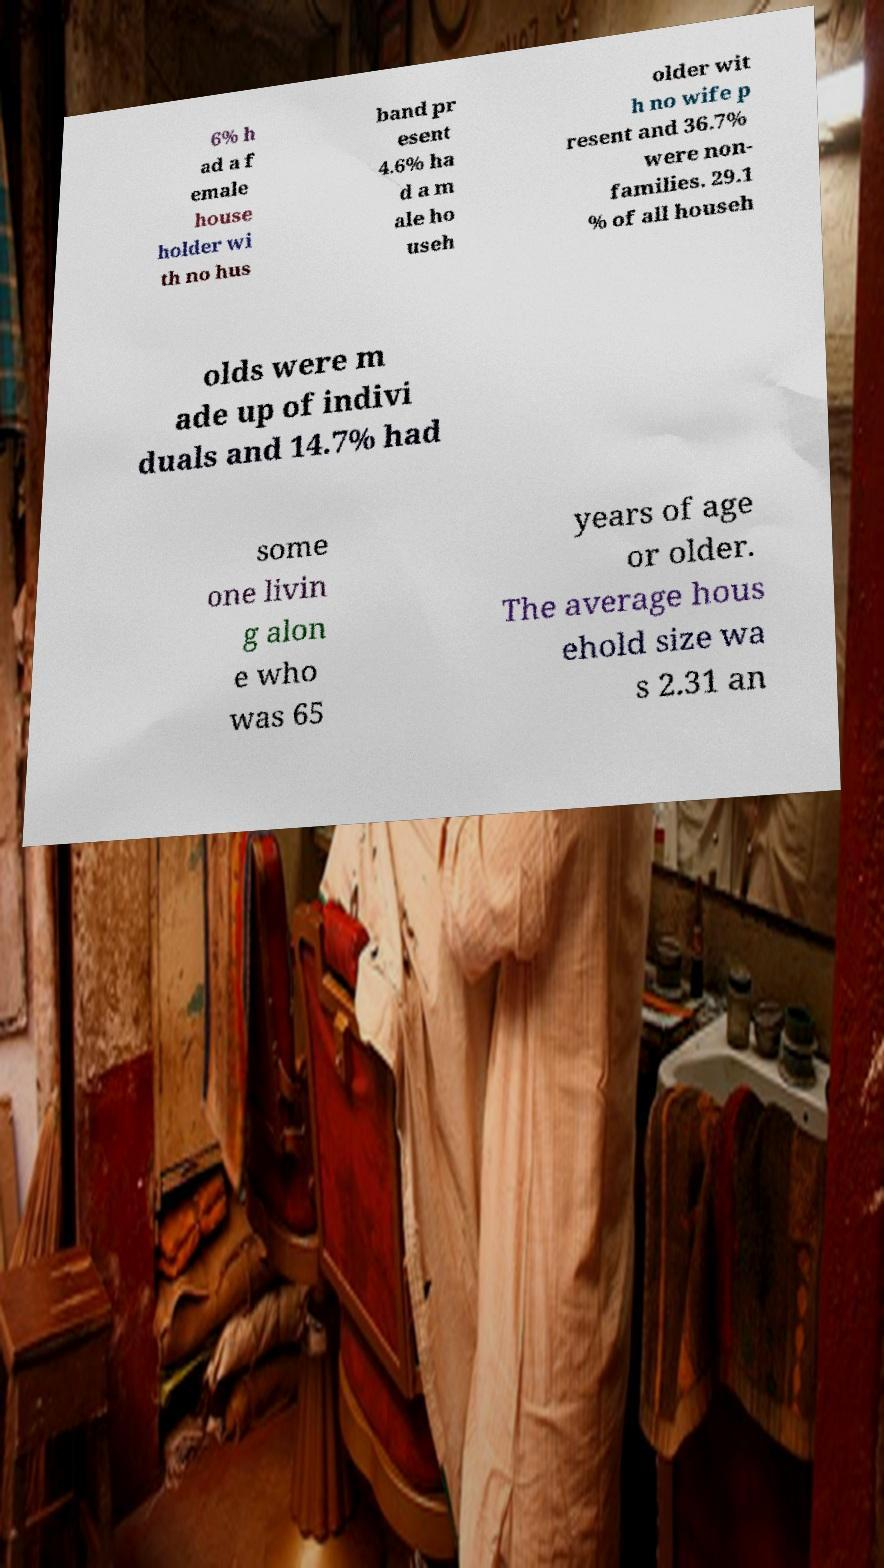What messages or text are displayed in this image? I need them in a readable, typed format. 6% h ad a f emale house holder wi th no hus band pr esent 4.6% ha d a m ale ho useh older wit h no wife p resent and 36.7% were non- families. 29.1 % of all househ olds were m ade up of indivi duals and 14.7% had some one livin g alon e who was 65 years of age or older. The average hous ehold size wa s 2.31 an 